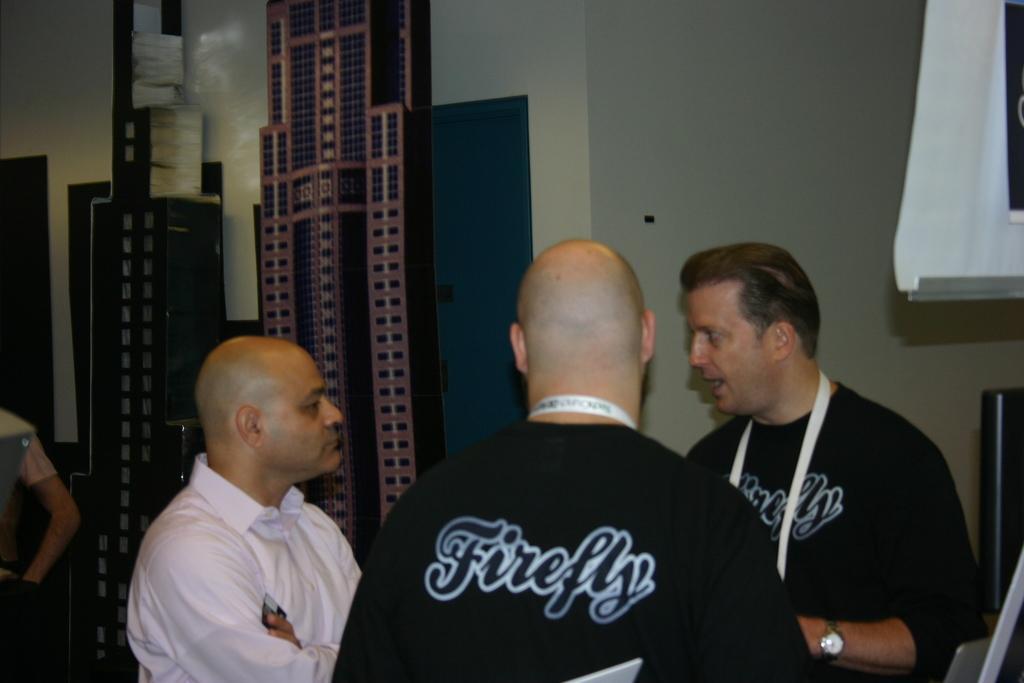How would you summarize this image in a sentence or two? In this image I can see two persons wearing black colored dresses and a person wearing white colored dress. In the background I can see the wall, a person standing and few other objects. 